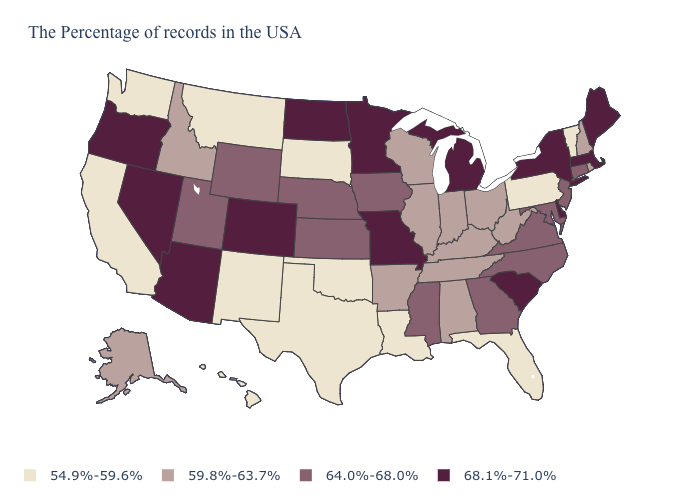Name the states that have a value in the range 68.1%-71.0%?
Give a very brief answer. Maine, Massachusetts, New York, Delaware, South Carolina, Michigan, Missouri, Minnesota, North Dakota, Colorado, Arizona, Nevada, Oregon. Does Illinois have the highest value in the MidWest?
Answer briefly. No. Name the states that have a value in the range 54.9%-59.6%?
Be succinct. Vermont, Pennsylvania, Florida, Louisiana, Oklahoma, Texas, South Dakota, New Mexico, Montana, California, Washington, Hawaii. What is the value of Alaska?
Answer briefly. 59.8%-63.7%. Is the legend a continuous bar?
Short answer required. No. What is the lowest value in the USA?
Concise answer only. 54.9%-59.6%. What is the highest value in states that border Ohio?
Answer briefly. 68.1%-71.0%. Name the states that have a value in the range 64.0%-68.0%?
Quick response, please. Connecticut, New Jersey, Maryland, Virginia, North Carolina, Georgia, Mississippi, Iowa, Kansas, Nebraska, Wyoming, Utah. What is the value of Alabama?
Give a very brief answer. 59.8%-63.7%. What is the lowest value in states that border Pennsylvania?
Answer briefly. 59.8%-63.7%. Does Nevada have the highest value in the USA?
Concise answer only. Yes. What is the lowest value in states that border Alabama?
Answer briefly. 54.9%-59.6%. Does Utah have the same value as Florida?
Be succinct. No. What is the lowest value in states that border Wisconsin?
Concise answer only. 59.8%-63.7%. What is the highest value in the USA?
Quick response, please. 68.1%-71.0%. 